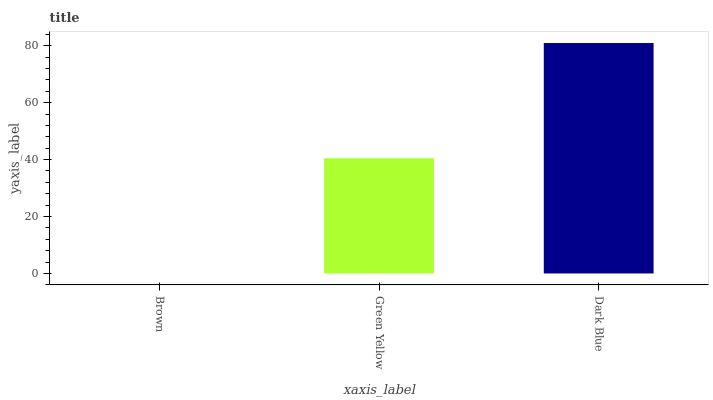Is Brown the minimum?
Answer yes or no. Yes. Is Dark Blue the maximum?
Answer yes or no. Yes. Is Green Yellow the minimum?
Answer yes or no. No. Is Green Yellow the maximum?
Answer yes or no. No. Is Green Yellow greater than Brown?
Answer yes or no. Yes. Is Brown less than Green Yellow?
Answer yes or no. Yes. Is Brown greater than Green Yellow?
Answer yes or no. No. Is Green Yellow less than Brown?
Answer yes or no. No. Is Green Yellow the high median?
Answer yes or no. Yes. Is Green Yellow the low median?
Answer yes or no. Yes. Is Dark Blue the high median?
Answer yes or no. No. Is Dark Blue the low median?
Answer yes or no. No. 